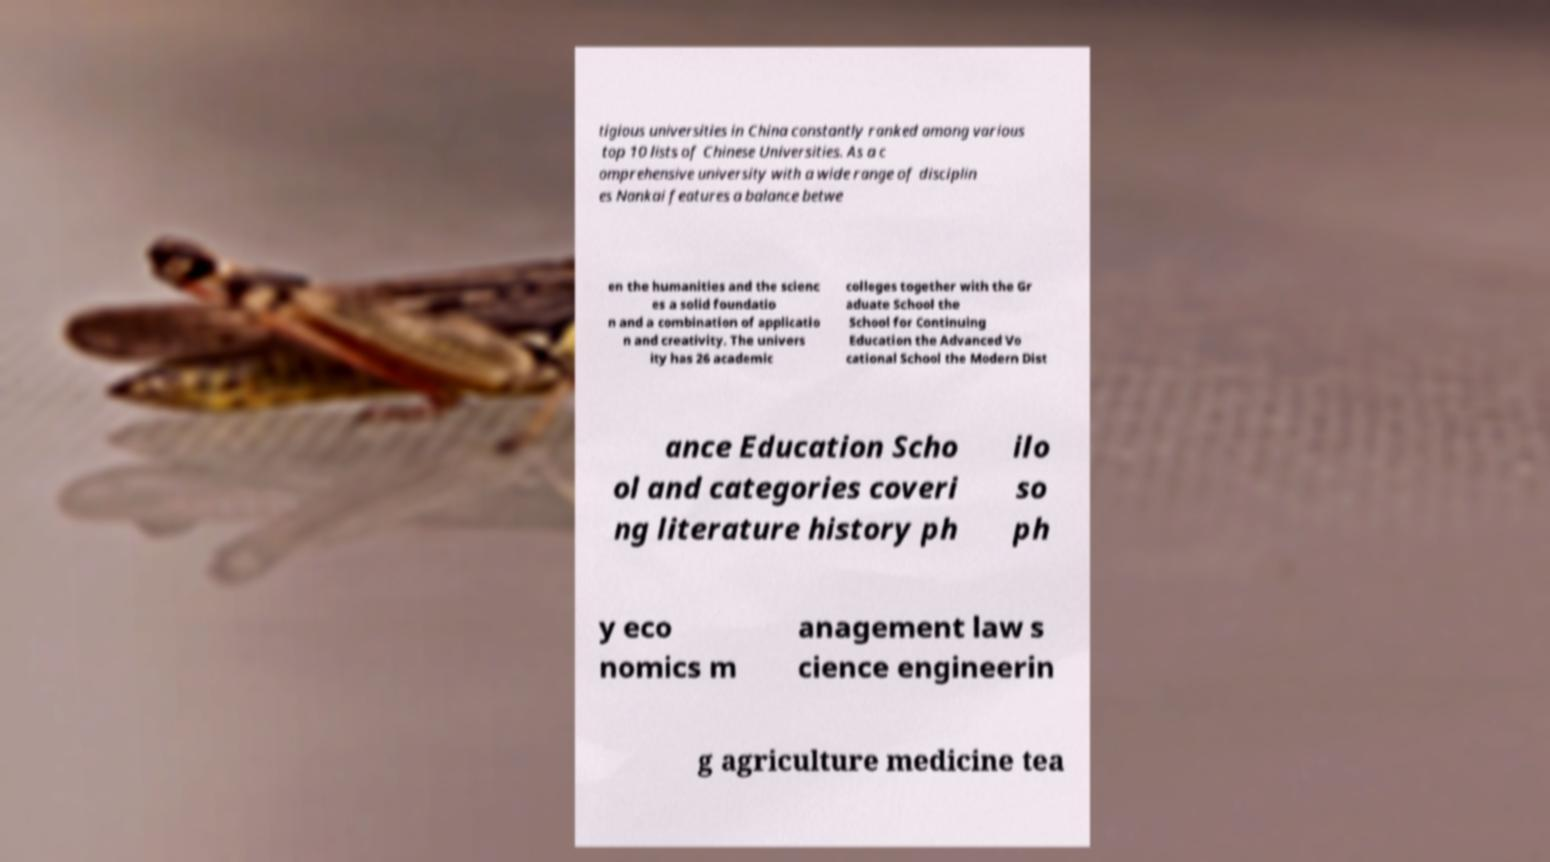Can you read and provide the text displayed in the image?This photo seems to have some interesting text. Can you extract and type it out for me? tigious universities in China constantly ranked among various top 10 lists of Chinese Universities. As a c omprehensive university with a wide range of disciplin es Nankai features a balance betwe en the humanities and the scienc es a solid foundatio n and a combination of applicatio n and creativity. The univers ity has 26 academic colleges together with the Gr aduate School the School for Continuing Education the Advanced Vo cational School the Modern Dist ance Education Scho ol and categories coveri ng literature history ph ilo so ph y eco nomics m anagement law s cience engineerin g agriculture medicine tea 